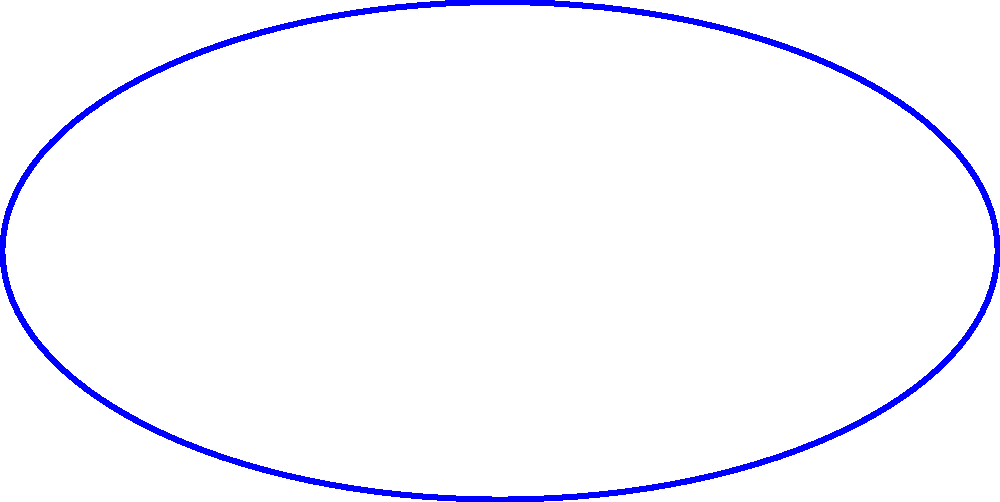Hey there, comedy genius! Time to put that quick wit to the test. Imagine you're crafting the perfect sarcastic smirk, but instead of using your face muscles, you're using math. Derive the equation of an ellipse that mimics this smirk, given that the distance between the foci is 4 units and the length of the major axis is 6 units. Oh, and don't forget to add a punchline at the end – I mean, the standard form of the equation! Alright, let's break this down step by step, with a side of humor:

1) First, we know that the distance between the foci is 4 units. Let's call this 2c. So:
   $2c = 4$
   $c = 2$

2) We're also told that the length of the major axis is 6 units. This is 2a in ellipse-speak. So:
   $2a = 6$
   $a = 3$

3) Now, we need to find b. In an ellipse, there's a golden relationship:
   $a^2 = b^2 + c^2$

4) Let's plug in what we know:
   $3^2 = b^2 + 2^2$
   $9 = b^2 + 4$
   $b^2 = 5$
   $b = \sqrt{5}$

5) Now, for the grand finale – the standard form of an ellipse equation is:
   $\frac{x^2}{a^2} + \frac{y^2}{b^2} = 1$

6) Plugging in our values:
   $\frac{x^2}{3^2} + \frac{y^2}{(\sqrt{5})^2} = 1$

7) Simplify:
   $\frac{x^2}{9} + \frac{y^2}{5} = 1$

And there you have it! The equation of your sarcastic smirk, mathematically defined. Remember, in geometry as in comedy, it's all about the delivery!
Answer: $\frac{x^2}{9} + \frac{y^2}{5} = 1$ 